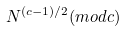Convert formula to latex. <formula><loc_0><loc_0><loc_500><loc_500>N ^ { ( c - 1 ) / 2 } ( m o d c )</formula> 